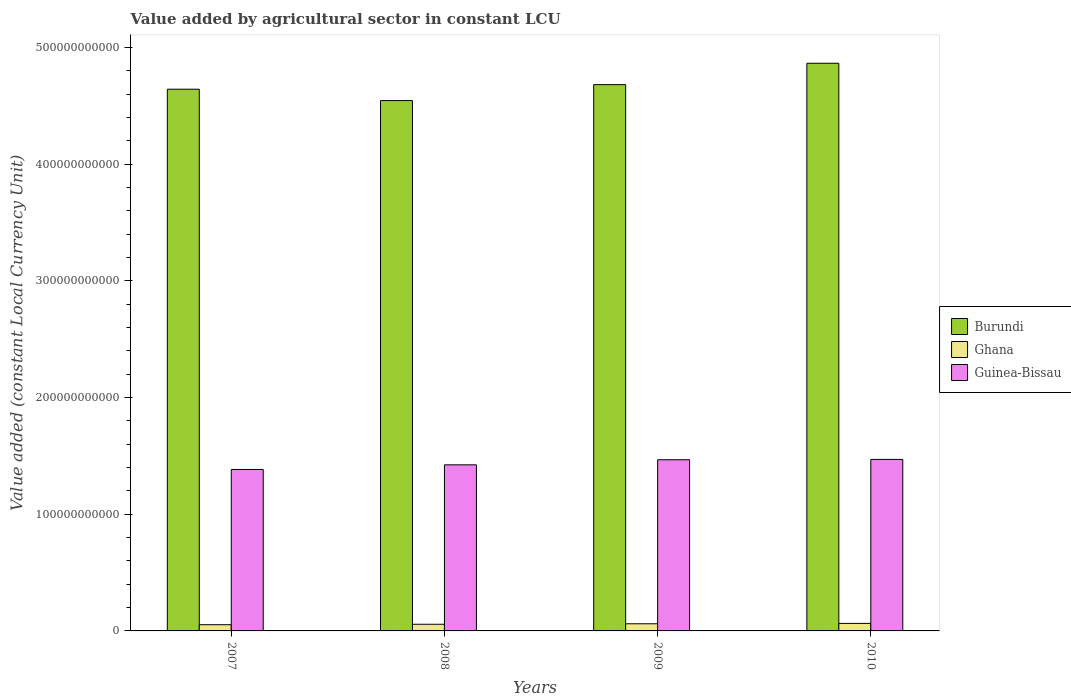How many different coloured bars are there?
Give a very brief answer. 3. Are the number of bars per tick equal to the number of legend labels?
Give a very brief answer. Yes. Are the number of bars on each tick of the X-axis equal?
Give a very brief answer. Yes. How many bars are there on the 3rd tick from the left?
Offer a very short reply. 3. What is the label of the 4th group of bars from the left?
Ensure brevity in your answer.  2010. In how many cases, is the number of bars for a given year not equal to the number of legend labels?
Your answer should be very brief. 0. What is the value added by agricultural sector in Ghana in 2010?
Make the answer very short. 6.45e+09. Across all years, what is the maximum value added by agricultural sector in Guinea-Bissau?
Keep it short and to the point. 1.47e+11. Across all years, what is the minimum value added by agricultural sector in Ghana?
Offer a terse response. 5.32e+09. What is the total value added by agricultural sector in Ghana in the graph?
Give a very brief answer. 2.36e+1. What is the difference between the value added by agricultural sector in Ghana in 2009 and that in 2010?
Your response must be concise. -3.23e+08. What is the difference between the value added by agricultural sector in Burundi in 2007 and the value added by agricultural sector in Guinea-Bissau in 2010?
Offer a terse response. 3.17e+11. What is the average value added by agricultural sector in Burundi per year?
Your answer should be compact. 4.68e+11. In the year 2009, what is the difference between the value added by agricultural sector in Ghana and value added by agricultural sector in Guinea-Bissau?
Provide a succinct answer. -1.41e+11. What is the ratio of the value added by agricultural sector in Guinea-Bissau in 2007 to that in 2008?
Provide a short and direct response. 0.97. Is the value added by agricultural sector in Ghana in 2009 less than that in 2010?
Make the answer very short. Yes. What is the difference between the highest and the second highest value added by agricultural sector in Ghana?
Give a very brief answer. 3.23e+08. What is the difference between the highest and the lowest value added by agricultural sector in Ghana?
Keep it short and to the point. 1.13e+09. In how many years, is the value added by agricultural sector in Burundi greater than the average value added by agricultural sector in Burundi taken over all years?
Your response must be concise. 1. What does the 1st bar from the left in 2010 represents?
Make the answer very short. Burundi. What does the 1st bar from the right in 2008 represents?
Make the answer very short. Guinea-Bissau. Is it the case that in every year, the sum of the value added by agricultural sector in Guinea-Bissau and value added by agricultural sector in Burundi is greater than the value added by agricultural sector in Ghana?
Your response must be concise. Yes. How many bars are there?
Provide a short and direct response. 12. What is the difference between two consecutive major ticks on the Y-axis?
Provide a succinct answer. 1.00e+11. Are the values on the major ticks of Y-axis written in scientific E-notation?
Offer a terse response. No. How many legend labels are there?
Your answer should be compact. 3. How are the legend labels stacked?
Provide a short and direct response. Vertical. What is the title of the graph?
Provide a short and direct response. Value added by agricultural sector in constant LCU. Does "European Union" appear as one of the legend labels in the graph?
Make the answer very short. No. What is the label or title of the X-axis?
Your response must be concise. Years. What is the label or title of the Y-axis?
Provide a short and direct response. Value added (constant Local Currency Unit). What is the Value added (constant Local Currency Unit) of Burundi in 2007?
Make the answer very short. 4.64e+11. What is the Value added (constant Local Currency Unit) of Ghana in 2007?
Offer a terse response. 5.32e+09. What is the Value added (constant Local Currency Unit) of Guinea-Bissau in 2007?
Provide a succinct answer. 1.38e+11. What is the Value added (constant Local Currency Unit) in Burundi in 2008?
Your answer should be compact. 4.55e+11. What is the Value added (constant Local Currency Unit) in Ghana in 2008?
Offer a very short reply. 5.72e+09. What is the Value added (constant Local Currency Unit) in Guinea-Bissau in 2008?
Keep it short and to the point. 1.42e+11. What is the Value added (constant Local Currency Unit) of Burundi in 2009?
Give a very brief answer. 4.68e+11. What is the Value added (constant Local Currency Unit) of Ghana in 2009?
Provide a short and direct response. 6.13e+09. What is the Value added (constant Local Currency Unit) of Guinea-Bissau in 2009?
Provide a short and direct response. 1.47e+11. What is the Value added (constant Local Currency Unit) of Burundi in 2010?
Offer a terse response. 4.87e+11. What is the Value added (constant Local Currency Unit) of Ghana in 2010?
Offer a terse response. 6.45e+09. What is the Value added (constant Local Currency Unit) of Guinea-Bissau in 2010?
Make the answer very short. 1.47e+11. Across all years, what is the maximum Value added (constant Local Currency Unit) in Burundi?
Offer a terse response. 4.87e+11. Across all years, what is the maximum Value added (constant Local Currency Unit) of Ghana?
Offer a terse response. 6.45e+09. Across all years, what is the maximum Value added (constant Local Currency Unit) of Guinea-Bissau?
Give a very brief answer. 1.47e+11. Across all years, what is the minimum Value added (constant Local Currency Unit) of Burundi?
Make the answer very short. 4.55e+11. Across all years, what is the minimum Value added (constant Local Currency Unit) of Ghana?
Give a very brief answer. 5.32e+09. Across all years, what is the minimum Value added (constant Local Currency Unit) in Guinea-Bissau?
Offer a very short reply. 1.38e+11. What is the total Value added (constant Local Currency Unit) in Burundi in the graph?
Offer a very short reply. 1.87e+12. What is the total Value added (constant Local Currency Unit) in Ghana in the graph?
Provide a succinct answer. 2.36e+1. What is the total Value added (constant Local Currency Unit) in Guinea-Bissau in the graph?
Keep it short and to the point. 5.74e+11. What is the difference between the Value added (constant Local Currency Unit) of Burundi in 2007 and that in 2008?
Offer a terse response. 9.76e+09. What is the difference between the Value added (constant Local Currency Unit) of Ghana in 2007 and that in 2008?
Ensure brevity in your answer.  -3.94e+08. What is the difference between the Value added (constant Local Currency Unit) of Guinea-Bissau in 2007 and that in 2008?
Provide a short and direct response. -3.96e+09. What is the difference between the Value added (constant Local Currency Unit) in Burundi in 2007 and that in 2009?
Provide a short and direct response. -3.93e+09. What is the difference between the Value added (constant Local Currency Unit) in Ghana in 2007 and that in 2009?
Offer a very short reply. -8.07e+08. What is the difference between the Value added (constant Local Currency Unit) in Guinea-Bissau in 2007 and that in 2009?
Ensure brevity in your answer.  -8.34e+09. What is the difference between the Value added (constant Local Currency Unit) of Burundi in 2007 and that in 2010?
Keep it short and to the point. -2.22e+1. What is the difference between the Value added (constant Local Currency Unit) in Ghana in 2007 and that in 2010?
Your response must be concise. -1.13e+09. What is the difference between the Value added (constant Local Currency Unit) of Guinea-Bissau in 2007 and that in 2010?
Give a very brief answer. -8.61e+09. What is the difference between the Value added (constant Local Currency Unit) in Burundi in 2008 and that in 2009?
Your answer should be compact. -1.37e+1. What is the difference between the Value added (constant Local Currency Unit) in Ghana in 2008 and that in 2009?
Provide a short and direct response. -4.13e+08. What is the difference between the Value added (constant Local Currency Unit) of Guinea-Bissau in 2008 and that in 2009?
Offer a terse response. -4.38e+09. What is the difference between the Value added (constant Local Currency Unit) of Burundi in 2008 and that in 2010?
Offer a very short reply. -3.20e+1. What is the difference between the Value added (constant Local Currency Unit) of Ghana in 2008 and that in 2010?
Make the answer very short. -7.36e+08. What is the difference between the Value added (constant Local Currency Unit) of Guinea-Bissau in 2008 and that in 2010?
Provide a short and direct response. -4.64e+09. What is the difference between the Value added (constant Local Currency Unit) in Burundi in 2009 and that in 2010?
Give a very brief answer. -1.83e+1. What is the difference between the Value added (constant Local Currency Unit) of Ghana in 2009 and that in 2010?
Provide a succinct answer. -3.23e+08. What is the difference between the Value added (constant Local Currency Unit) of Guinea-Bissau in 2009 and that in 2010?
Provide a succinct answer. -2.68e+08. What is the difference between the Value added (constant Local Currency Unit) in Burundi in 2007 and the Value added (constant Local Currency Unit) in Ghana in 2008?
Provide a short and direct response. 4.59e+11. What is the difference between the Value added (constant Local Currency Unit) in Burundi in 2007 and the Value added (constant Local Currency Unit) in Guinea-Bissau in 2008?
Provide a succinct answer. 3.22e+11. What is the difference between the Value added (constant Local Currency Unit) of Ghana in 2007 and the Value added (constant Local Currency Unit) of Guinea-Bissau in 2008?
Provide a succinct answer. -1.37e+11. What is the difference between the Value added (constant Local Currency Unit) in Burundi in 2007 and the Value added (constant Local Currency Unit) in Ghana in 2009?
Make the answer very short. 4.58e+11. What is the difference between the Value added (constant Local Currency Unit) in Burundi in 2007 and the Value added (constant Local Currency Unit) in Guinea-Bissau in 2009?
Make the answer very short. 3.18e+11. What is the difference between the Value added (constant Local Currency Unit) of Ghana in 2007 and the Value added (constant Local Currency Unit) of Guinea-Bissau in 2009?
Offer a terse response. -1.41e+11. What is the difference between the Value added (constant Local Currency Unit) in Burundi in 2007 and the Value added (constant Local Currency Unit) in Ghana in 2010?
Your response must be concise. 4.58e+11. What is the difference between the Value added (constant Local Currency Unit) of Burundi in 2007 and the Value added (constant Local Currency Unit) of Guinea-Bissau in 2010?
Offer a terse response. 3.17e+11. What is the difference between the Value added (constant Local Currency Unit) of Ghana in 2007 and the Value added (constant Local Currency Unit) of Guinea-Bissau in 2010?
Your answer should be very brief. -1.42e+11. What is the difference between the Value added (constant Local Currency Unit) of Burundi in 2008 and the Value added (constant Local Currency Unit) of Ghana in 2009?
Provide a succinct answer. 4.48e+11. What is the difference between the Value added (constant Local Currency Unit) of Burundi in 2008 and the Value added (constant Local Currency Unit) of Guinea-Bissau in 2009?
Your response must be concise. 3.08e+11. What is the difference between the Value added (constant Local Currency Unit) in Ghana in 2008 and the Value added (constant Local Currency Unit) in Guinea-Bissau in 2009?
Provide a succinct answer. -1.41e+11. What is the difference between the Value added (constant Local Currency Unit) in Burundi in 2008 and the Value added (constant Local Currency Unit) in Ghana in 2010?
Keep it short and to the point. 4.48e+11. What is the difference between the Value added (constant Local Currency Unit) of Burundi in 2008 and the Value added (constant Local Currency Unit) of Guinea-Bissau in 2010?
Offer a terse response. 3.08e+11. What is the difference between the Value added (constant Local Currency Unit) in Ghana in 2008 and the Value added (constant Local Currency Unit) in Guinea-Bissau in 2010?
Give a very brief answer. -1.41e+11. What is the difference between the Value added (constant Local Currency Unit) in Burundi in 2009 and the Value added (constant Local Currency Unit) in Ghana in 2010?
Your response must be concise. 4.62e+11. What is the difference between the Value added (constant Local Currency Unit) of Burundi in 2009 and the Value added (constant Local Currency Unit) of Guinea-Bissau in 2010?
Your answer should be compact. 3.21e+11. What is the difference between the Value added (constant Local Currency Unit) of Ghana in 2009 and the Value added (constant Local Currency Unit) of Guinea-Bissau in 2010?
Keep it short and to the point. -1.41e+11. What is the average Value added (constant Local Currency Unit) in Burundi per year?
Your answer should be very brief. 4.68e+11. What is the average Value added (constant Local Currency Unit) of Ghana per year?
Provide a short and direct response. 5.90e+09. What is the average Value added (constant Local Currency Unit) in Guinea-Bissau per year?
Make the answer very short. 1.44e+11. In the year 2007, what is the difference between the Value added (constant Local Currency Unit) of Burundi and Value added (constant Local Currency Unit) of Ghana?
Keep it short and to the point. 4.59e+11. In the year 2007, what is the difference between the Value added (constant Local Currency Unit) in Burundi and Value added (constant Local Currency Unit) in Guinea-Bissau?
Your answer should be compact. 3.26e+11. In the year 2007, what is the difference between the Value added (constant Local Currency Unit) in Ghana and Value added (constant Local Currency Unit) in Guinea-Bissau?
Provide a succinct answer. -1.33e+11. In the year 2008, what is the difference between the Value added (constant Local Currency Unit) in Burundi and Value added (constant Local Currency Unit) in Ghana?
Provide a short and direct response. 4.49e+11. In the year 2008, what is the difference between the Value added (constant Local Currency Unit) in Burundi and Value added (constant Local Currency Unit) in Guinea-Bissau?
Provide a short and direct response. 3.12e+11. In the year 2008, what is the difference between the Value added (constant Local Currency Unit) of Ghana and Value added (constant Local Currency Unit) of Guinea-Bissau?
Make the answer very short. -1.37e+11. In the year 2009, what is the difference between the Value added (constant Local Currency Unit) of Burundi and Value added (constant Local Currency Unit) of Ghana?
Your answer should be very brief. 4.62e+11. In the year 2009, what is the difference between the Value added (constant Local Currency Unit) in Burundi and Value added (constant Local Currency Unit) in Guinea-Bissau?
Keep it short and to the point. 3.21e+11. In the year 2009, what is the difference between the Value added (constant Local Currency Unit) of Ghana and Value added (constant Local Currency Unit) of Guinea-Bissau?
Keep it short and to the point. -1.41e+11. In the year 2010, what is the difference between the Value added (constant Local Currency Unit) in Burundi and Value added (constant Local Currency Unit) in Ghana?
Offer a terse response. 4.80e+11. In the year 2010, what is the difference between the Value added (constant Local Currency Unit) of Burundi and Value added (constant Local Currency Unit) of Guinea-Bissau?
Offer a terse response. 3.40e+11. In the year 2010, what is the difference between the Value added (constant Local Currency Unit) in Ghana and Value added (constant Local Currency Unit) in Guinea-Bissau?
Give a very brief answer. -1.41e+11. What is the ratio of the Value added (constant Local Currency Unit) in Burundi in 2007 to that in 2008?
Provide a succinct answer. 1.02. What is the ratio of the Value added (constant Local Currency Unit) in Ghana in 2007 to that in 2008?
Your answer should be very brief. 0.93. What is the ratio of the Value added (constant Local Currency Unit) of Guinea-Bissau in 2007 to that in 2008?
Make the answer very short. 0.97. What is the ratio of the Value added (constant Local Currency Unit) of Ghana in 2007 to that in 2009?
Make the answer very short. 0.87. What is the ratio of the Value added (constant Local Currency Unit) in Guinea-Bissau in 2007 to that in 2009?
Provide a succinct answer. 0.94. What is the ratio of the Value added (constant Local Currency Unit) of Burundi in 2007 to that in 2010?
Offer a very short reply. 0.95. What is the ratio of the Value added (constant Local Currency Unit) of Ghana in 2007 to that in 2010?
Your response must be concise. 0.82. What is the ratio of the Value added (constant Local Currency Unit) in Guinea-Bissau in 2007 to that in 2010?
Offer a very short reply. 0.94. What is the ratio of the Value added (constant Local Currency Unit) in Burundi in 2008 to that in 2009?
Keep it short and to the point. 0.97. What is the ratio of the Value added (constant Local Currency Unit) of Ghana in 2008 to that in 2009?
Your response must be concise. 0.93. What is the ratio of the Value added (constant Local Currency Unit) in Guinea-Bissau in 2008 to that in 2009?
Keep it short and to the point. 0.97. What is the ratio of the Value added (constant Local Currency Unit) of Burundi in 2008 to that in 2010?
Offer a terse response. 0.93. What is the ratio of the Value added (constant Local Currency Unit) in Ghana in 2008 to that in 2010?
Ensure brevity in your answer.  0.89. What is the ratio of the Value added (constant Local Currency Unit) in Guinea-Bissau in 2008 to that in 2010?
Provide a short and direct response. 0.97. What is the ratio of the Value added (constant Local Currency Unit) in Burundi in 2009 to that in 2010?
Your answer should be very brief. 0.96. What is the ratio of the Value added (constant Local Currency Unit) in Ghana in 2009 to that in 2010?
Make the answer very short. 0.95. What is the ratio of the Value added (constant Local Currency Unit) in Guinea-Bissau in 2009 to that in 2010?
Provide a short and direct response. 1. What is the difference between the highest and the second highest Value added (constant Local Currency Unit) in Burundi?
Offer a terse response. 1.83e+1. What is the difference between the highest and the second highest Value added (constant Local Currency Unit) of Ghana?
Offer a very short reply. 3.23e+08. What is the difference between the highest and the second highest Value added (constant Local Currency Unit) of Guinea-Bissau?
Give a very brief answer. 2.68e+08. What is the difference between the highest and the lowest Value added (constant Local Currency Unit) of Burundi?
Offer a terse response. 3.20e+1. What is the difference between the highest and the lowest Value added (constant Local Currency Unit) of Ghana?
Your response must be concise. 1.13e+09. What is the difference between the highest and the lowest Value added (constant Local Currency Unit) of Guinea-Bissau?
Give a very brief answer. 8.61e+09. 